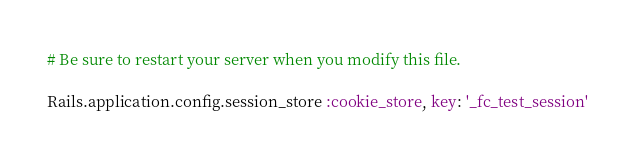<code> <loc_0><loc_0><loc_500><loc_500><_Ruby_># Be sure to restart your server when you modify this file.

Rails.application.config.session_store :cookie_store, key: '_fc_test_session'
</code> 